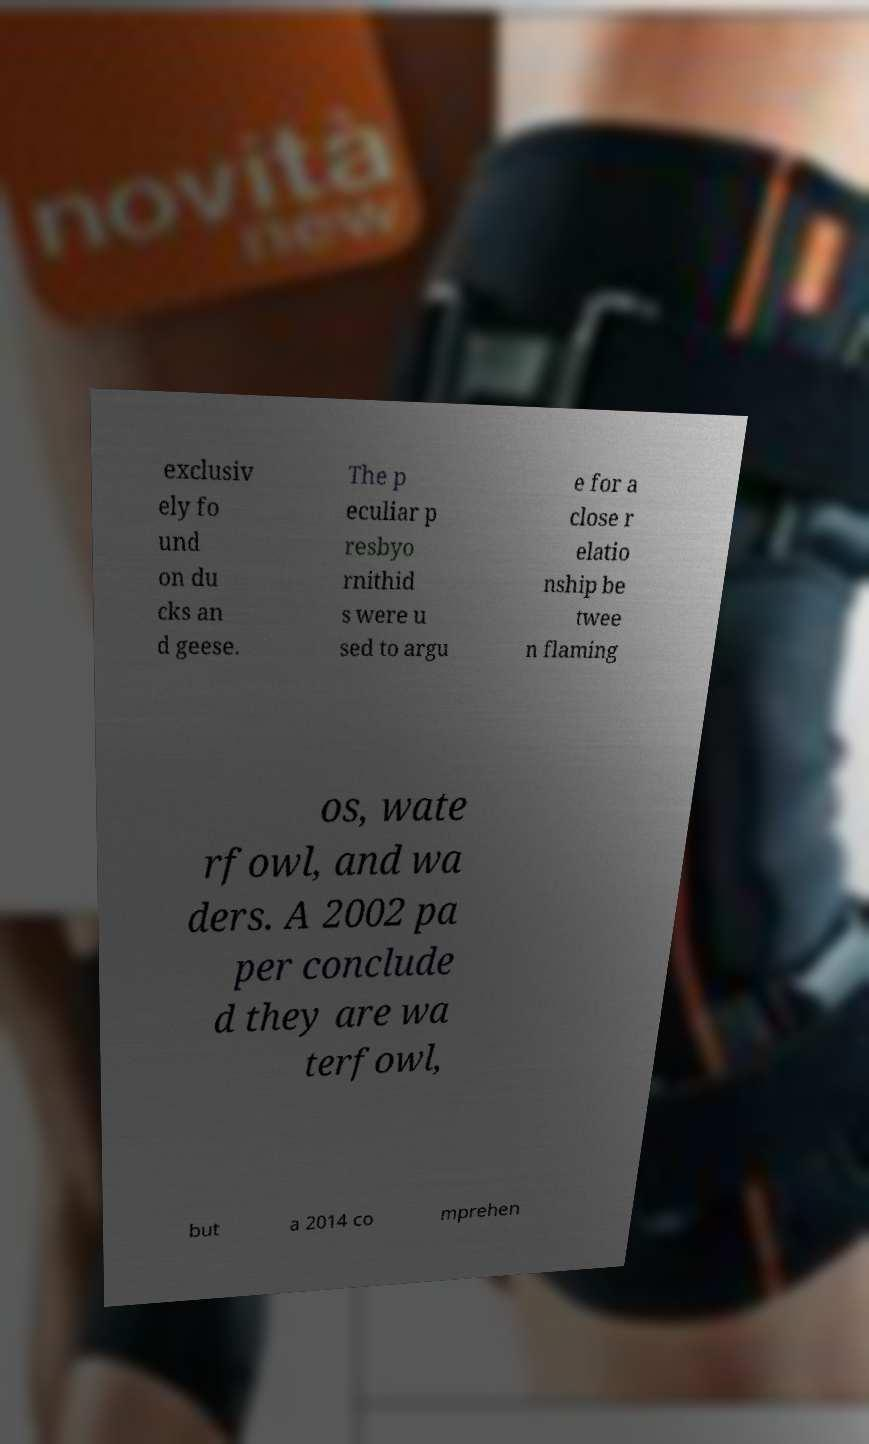What messages or text are displayed in this image? I need them in a readable, typed format. exclusiv ely fo und on du cks an d geese. The p eculiar p resbyo rnithid s were u sed to argu e for a close r elatio nship be twee n flaming os, wate rfowl, and wa ders. A 2002 pa per conclude d they are wa terfowl, but a 2014 co mprehen 